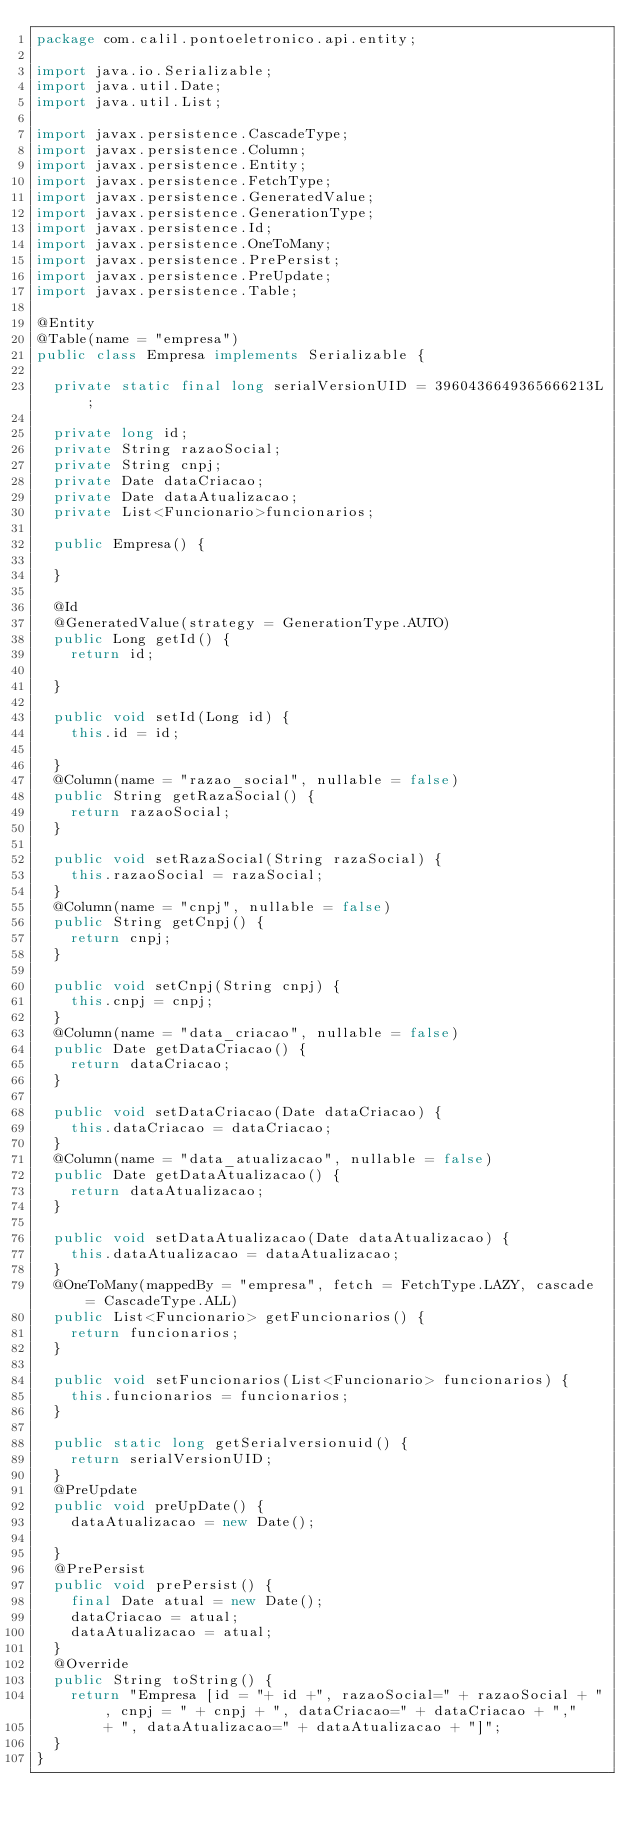<code> <loc_0><loc_0><loc_500><loc_500><_Java_>package com.calil.pontoeletronico.api.entity;

import java.io.Serializable;
import java.util.Date;
import java.util.List;

import javax.persistence.CascadeType;
import javax.persistence.Column;
import javax.persistence.Entity;
import javax.persistence.FetchType;
import javax.persistence.GeneratedValue;
import javax.persistence.GenerationType;
import javax.persistence.Id;
import javax.persistence.OneToMany;
import javax.persistence.PrePersist;
import javax.persistence.PreUpdate;
import javax.persistence.Table;

@Entity
@Table(name = "empresa")
public class Empresa implements Serializable {
	
	private static final long serialVersionUID = 3960436649365666213L;
	
	private long id;
	private String razaoSocial;
	private String cnpj;
	private Date dataCriacao;
	private Date dataAtualizacao;
	private List<Funcionario>funcionarios;
	
	public Empresa() {
		
	}
	
	@Id
	@GeneratedValue(strategy = GenerationType.AUTO)
	public Long getId() {
		return id;
	
	}
	
	public void setId(Long id) {
		this.id = id;
		
	}
	@Column(name = "razao_social", nullable = false)
	public String getRazaSocial() {
		return razaoSocial;
	}

	public void setRazaSocial(String razaSocial) {
		this.razaoSocial = razaSocial;
	}
	@Column(name = "cnpj", nullable = false)
	public String getCnpj() {
		return cnpj;
	}

	public void setCnpj(String cnpj) {
		this.cnpj = cnpj;
	}
	@Column(name = "data_criacao", nullable = false)
	public Date getDataCriacao() {
		return dataCriacao;
	}

	public void setDataCriacao(Date dataCriacao) {
		this.dataCriacao = dataCriacao;
	}
	@Column(name = "data_atualizacao", nullable = false)
	public Date getDataAtualizacao() {
		return dataAtualizacao;
	}

	public void setDataAtualizacao(Date dataAtualizacao) {
		this.dataAtualizacao = dataAtualizacao;
	}
	@OneToMany(mappedBy = "empresa", fetch = FetchType.LAZY, cascade = CascadeType.ALL)
	public List<Funcionario> getFuncionarios() {
		return funcionarios;
	}

	public void setFuncionarios(List<Funcionario> funcionarios) {
		this.funcionarios = funcionarios;
	}

	public static long getSerialversionuid() {
		return serialVersionUID;
	}
	@PreUpdate
	public void preUpDate() {
		dataAtualizacao = new Date();
		
	}
	@PrePersist
	public void prePersist() {
		final Date atual = new Date();
		dataCriacao = atual;
		dataAtualizacao = atual;
	}
	@Override
	public String toString() {
		return "Empresa [id = "+ id +", razaoSocial=" + razaoSocial + ", cnpj = " + cnpj + ", dataCriacao=" + dataCriacao + ","
				+ ", dataAtualizacao=" + dataAtualizacao + "]";
	}
}
</code> 